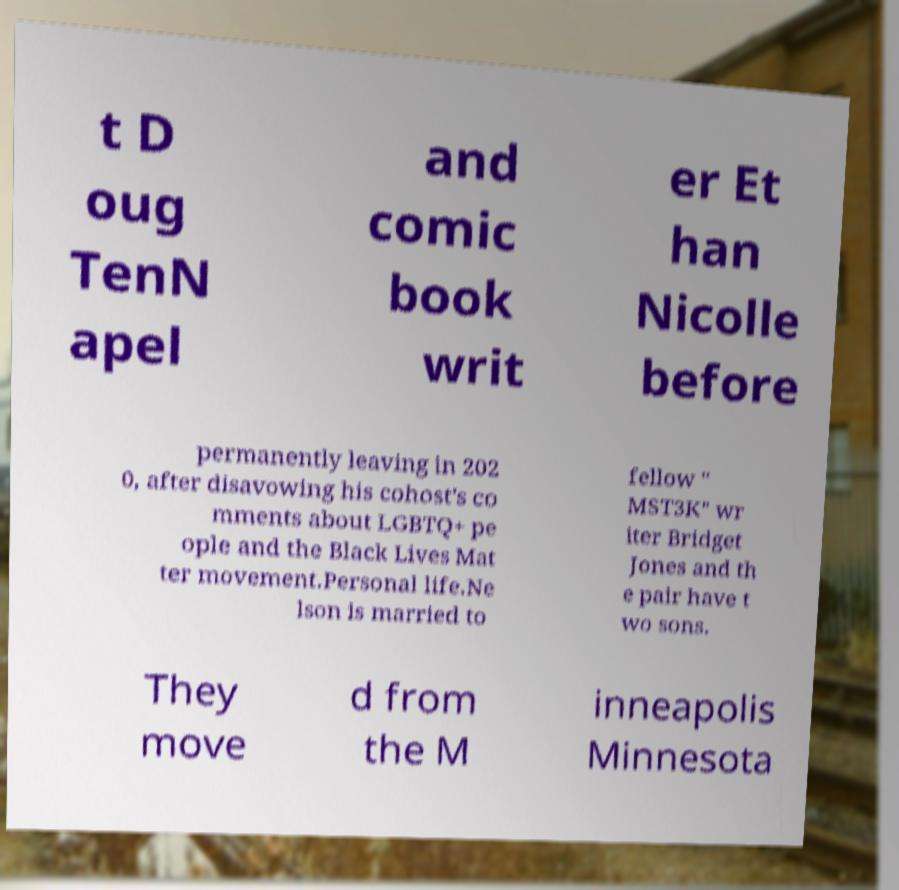What messages or text are displayed in this image? I need them in a readable, typed format. t D oug TenN apel and comic book writ er Et han Nicolle before permanently leaving in 202 0, after disavowing his cohost's co mments about LGBTQ+ pe ople and the Black Lives Mat ter movement.Personal life.Ne lson is married to fellow " MST3K" wr iter Bridget Jones and th e pair have t wo sons. They move d from the M inneapolis Minnesota 